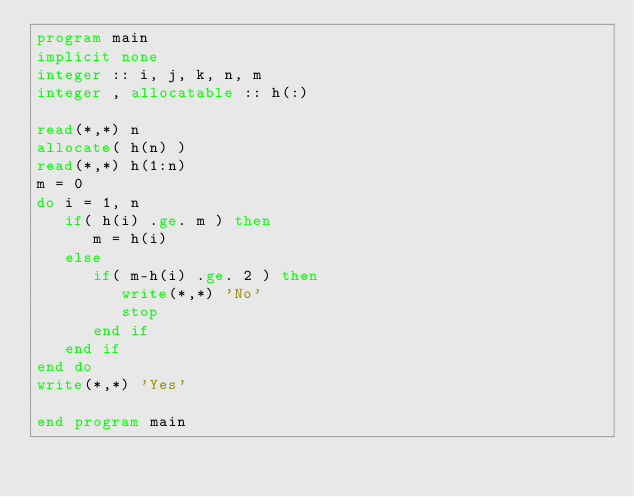<code> <loc_0><loc_0><loc_500><loc_500><_FORTRAN_>program main
implicit none
integer :: i, j, k, n, m
integer , allocatable :: h(:)

read(*,*) n
allocate( h(n) )
read(*,*) h(1:n)
m = 0
do i = 1, n
   if( h(i) .ge. m ) then
      m = h(i)
   else
      if( m-h(i) .ge. 2 ) then
         write(*,*) 'No'
         stop
      end if
   end if
end do
write(*,*) 'Yes'

end program main</code> 